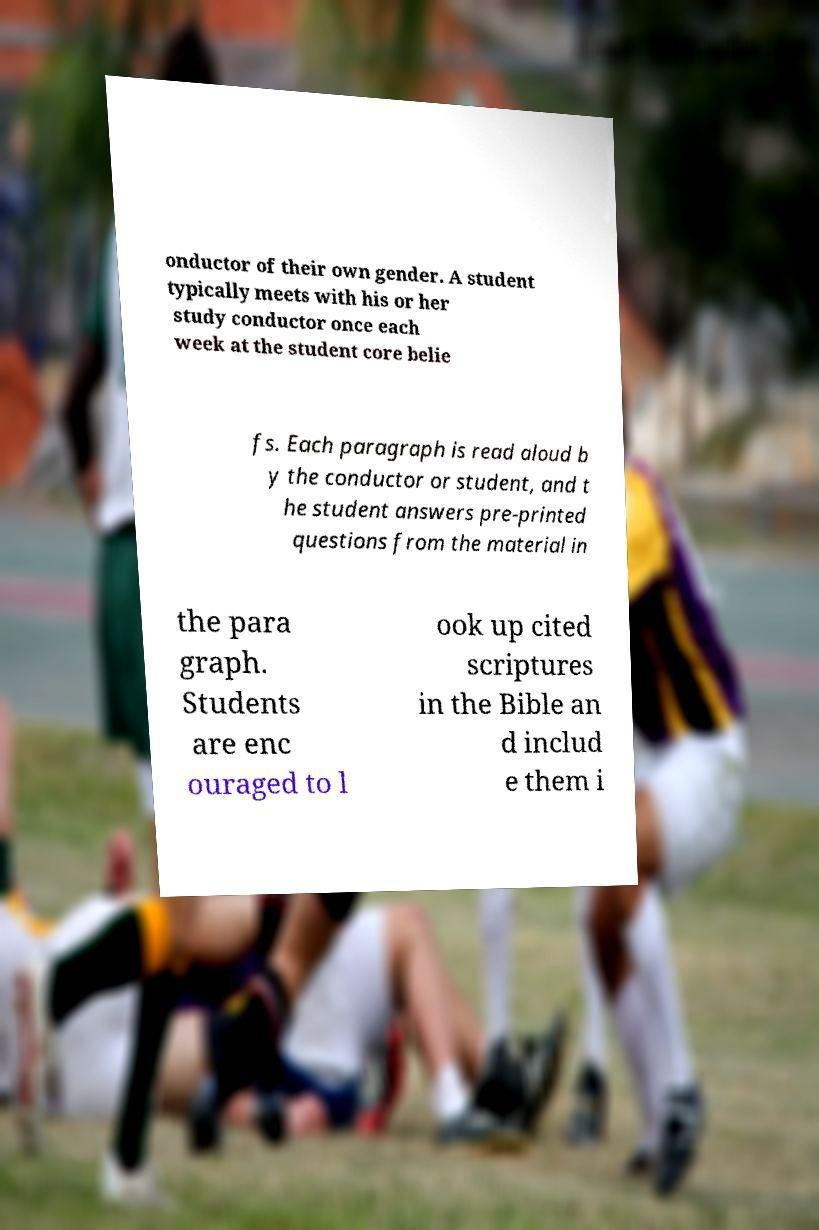There's text embedded in this image that I need extracted. Can you transcribe it verbatim? onductor of their own gender. A student typically meets with his or her study conductor once each week at the student core belie fs. Each paragraph is read aloud b y the conductor or student, and t he student answers pre-printed questions from the material in the para graph. Students are enc ouraged to l ook up cited scriptures in the Bible an d includ e them i 